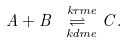Convert formula to latex. <formula><loc_0><loc_0><loc_500><loc_500>A + B \overset { \ k r m e } { \underset { \ k d m e } { \rightleftharpoons } } C .</formula> 